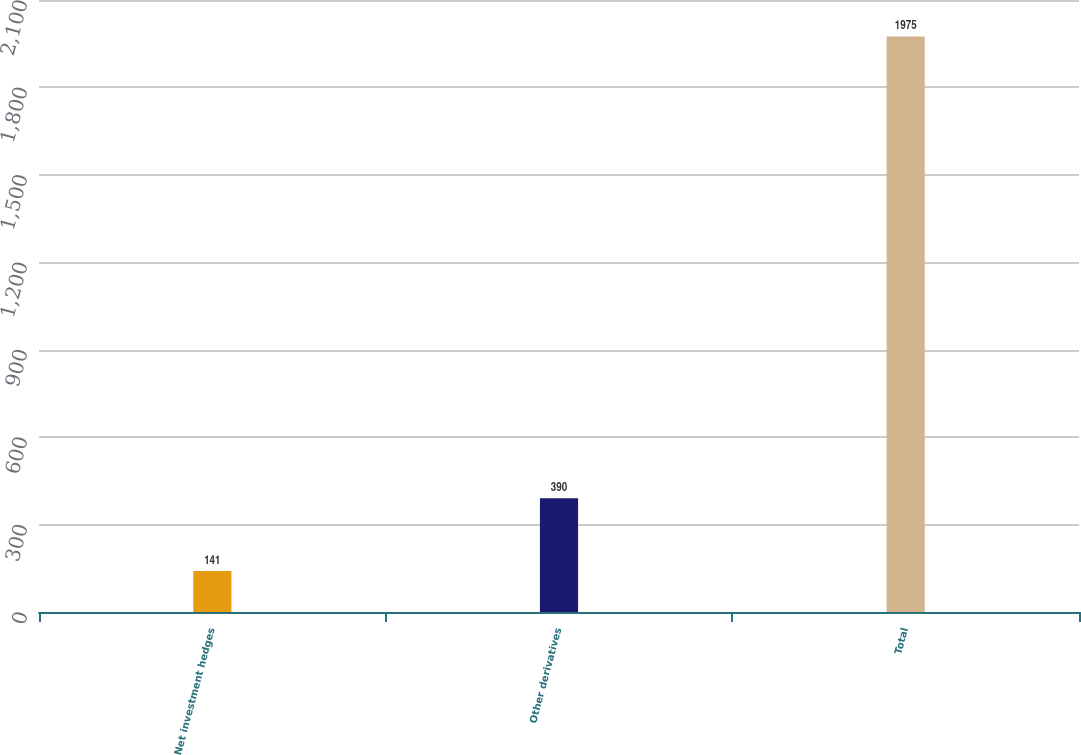Convert chart to OTSL. <chart><loc_0><loc_0><loc_500><loc_500><bar_chart><fcel>Net investment hedges<fcel>Other derivatives<fcel>Total<nl><fcel>141<fcel>390<fcel>1975<nl></chart> 